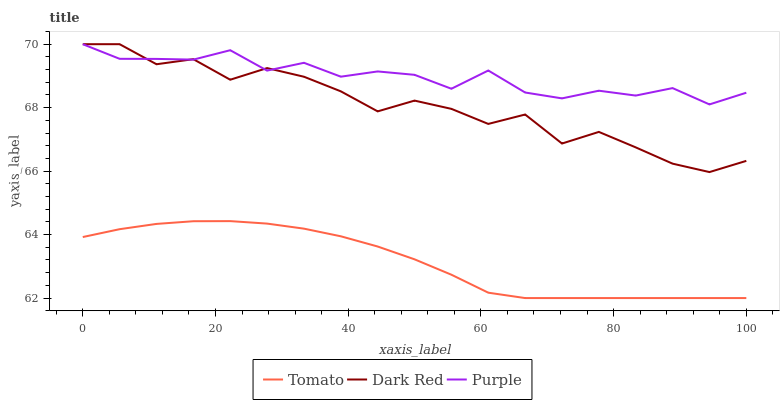Does Tomato have the minimum area under the curve?
Answer yes or no. Yes. Does Purple have the maximum area under the curve?
Answer yes or no. Yes. Does Dark Red have the minimum area under the curve?
Answer yes or no. No. Does Dark Red have the maximum area under the curve?
Answer yes or no. No. Is Tomato the smoothest?
Answer yes or no. Yes. Is Dark Red the roughest?
Answer yes or no. Yes. Is Purple the smoothest?
Answer yes or no. No. Is Purple the roughest?
Answer yes or no. No. Does Tomato have the lowest value?
Answer yes or no. Yes. Does Dark Red have the lowest value?
Answer yes or no. No. Does Purple have the highest value?
Answer yes or no. Yes. Is Tomato less than Purple?
Answer yes or no. Yes. Is Dark Red greater than Tomato?
Answer yes or no. Yes. Does Purple intersect Dark Red?
Answer yes or no. Yes. Is Purple less than Dark Red?
Answer yes or no. No. Is Purple greater than Dark Red?
Answer yes or no. No. Does Tomato intersect Purple?
Answer yes or no. No. 